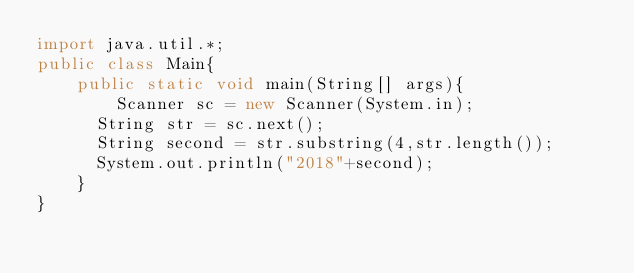Convert code to text. <code><loc_0><loc_0><loc_500><loc_500><_Java_>import java.util.*;
public class Main{
	public static void main(String[] args){
    	Scanner sc = new Scanner(System.in);
      String str = sc.next();
      String second = str.substring(4,str.length());
      System.out.println("2018"+second);
    }
}
</code> 